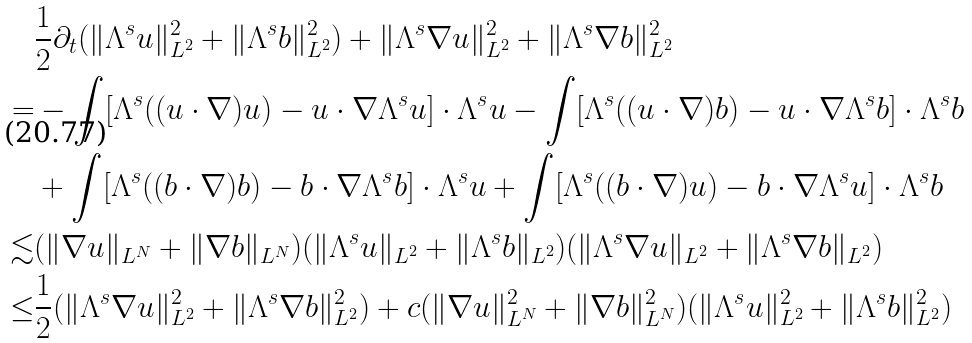Convert formula to latex. <formula><loc_0><loc_0><loc_500><loc_500>& \frac { 1 } { 2 } \partial _ { t } ( \| \Lambda ^ { s } u \| _ { L ^ { 2 } } ^ { 2 } + \| \Lambda ^ { s } b \| _ { L ^ { 2 } } ^ { 2 } ) + \| \Lambda ^ { s } \nabla u \| _ { L ^ { 2 } } ^ { 2 } + \| \Lambda ^ { s } \nabla b \| _ { L ^ { 2 } } ^ { 2 } \\ = & - \int [ \Lambda ^ { s } ( ( u \cdot \nabla ) u ) - u \cdot \nabla \Lambda ^ { s } u ] \cdot \Lambda ^ { s } u - \int [ \Lambda ^ { s } ( ( u \cdot \nabla ) b ) - u \cdot \nabla \Lambda ^ { s } b ] \cdot \Lambda ^ { s } b \\ & + \int [ \Lambda ^ { s } ( ( b \cdot \nabla ) b ) - b \cdot \nabla \Lambda ^ { s } b ] \cdot \Lambda ^ { s } u + \int [ \Lambda ^ { s } ( ( b \cdot \nabla ) u ) - b \cdot \nabla \Lambda ^ { s } u ] \cdot \Lambda ^ { s } b \\ \lesssim & ( \| \nabla u \| _ { L ^ { N } } + \| \nabla b \| _ { L ^ { N } } ) ( \| \Lambda ^ { s } u \| _ { L ^ { 2 } } + \| \Lambda ^ { s } b \| _ { L ^ { 2 } } ) ( \| \Lambda ^ { s } \nabla u \| _ { L ^ { 2 } } + \| \Lambda ^ { s } \nabla b \| _ { L ^ { 2 } } ) \\ \leq & \frac { 1 } { 2 } ( \| \Lambda ^ { s } \nabla u \| _ { L ^ { 2 } } ^ { 2 } + \| \Lambda ^ { s } \nabla b \| _ { L ^ { 2 } } ^ { 2 } ) + c ( \| \nabla u \| _ { L ^ { N } } ^ { 2 } + \| \nabla b \| _ { L ^ { N } } ^ { 2 } ) ( \| \Lambda ^ { s } u \| _ { L ^ { 2 } } ^ { 2 } + \| \Lambda ^ { s } b \| _ { L ^ { 2 } } ^ { 2 } )</formula> 